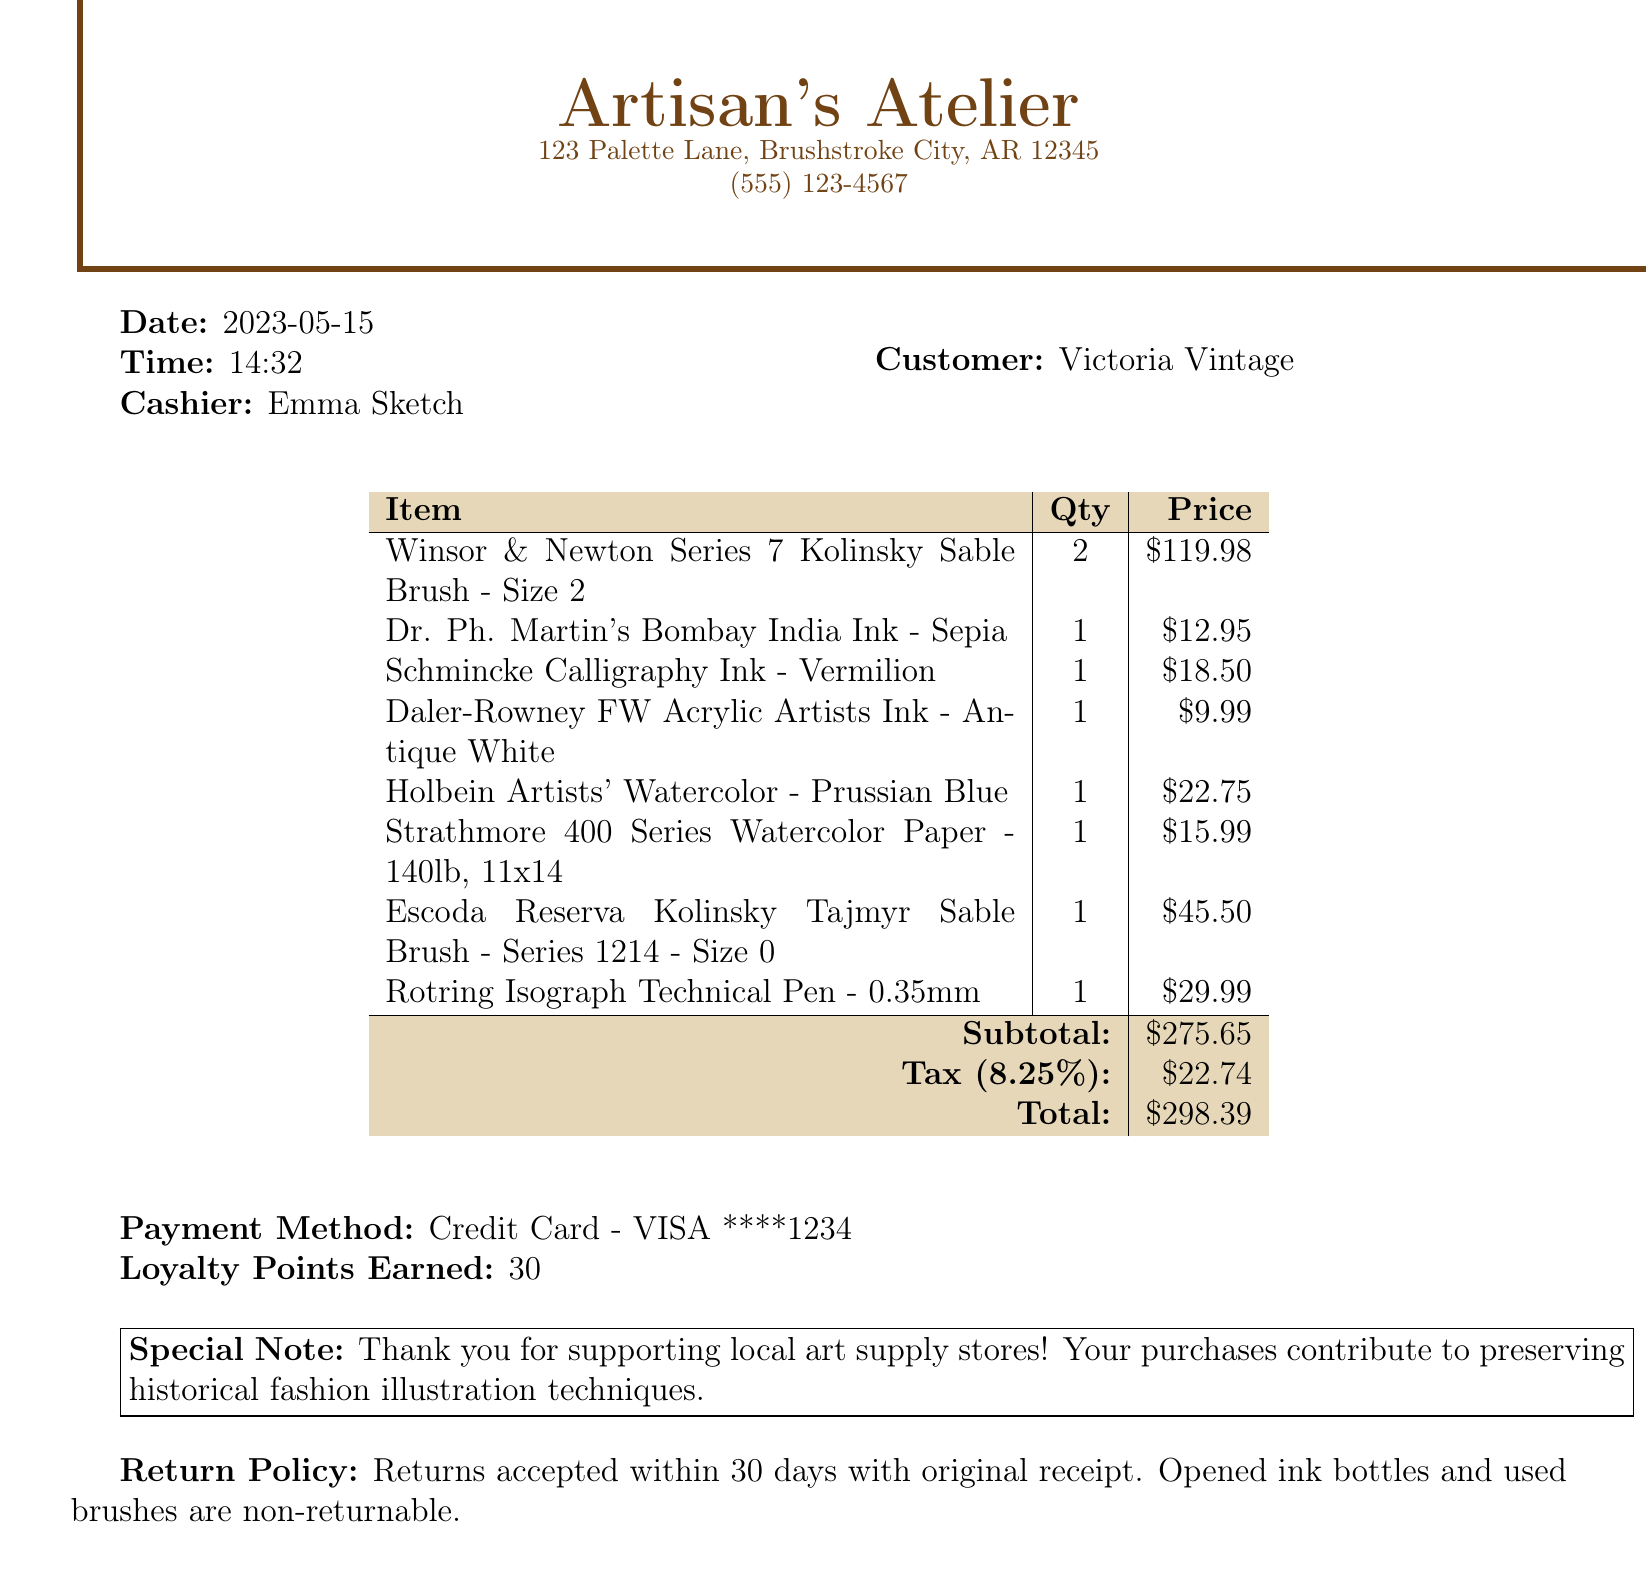What is the store name? The store name is clearly stated in the document as Artisan's Atelier.
Answer: Artisan's Atelier Who was the cashier on the receipt? The cashier's name is provided in the document as Emma Sketch.
Answer: Emma Sketch What is the date of the transaction? The date of the transaction is indicated as May 15, 2023.
Answer: 2023-05-15 How many brushes did the customer purchase? The document lists two different types of brushes with a total quantity of 3.
Answer: 3 What is the subtotal amount? The subtotal is stated in the document, summing the cost of items before tax.
Answer: $275.65 What is the tax rate applied in this transaction? The tax rate is mentioned in the document as 8.25%.
Answer: 8.25% What method of payment was used? The method of payment is specified in the document as Credit Card - VISA ****1234.
Answer: Credit Card - VISA ****1234 What is the return policy stated? The return policy is described in the document detailing conditions for returns.
Answer: Returns accepted within 30 days with original receipt What is the total amount for this purchase? The total amount is calculated in the document and is stated at the bottom.
Answer: $298.39 